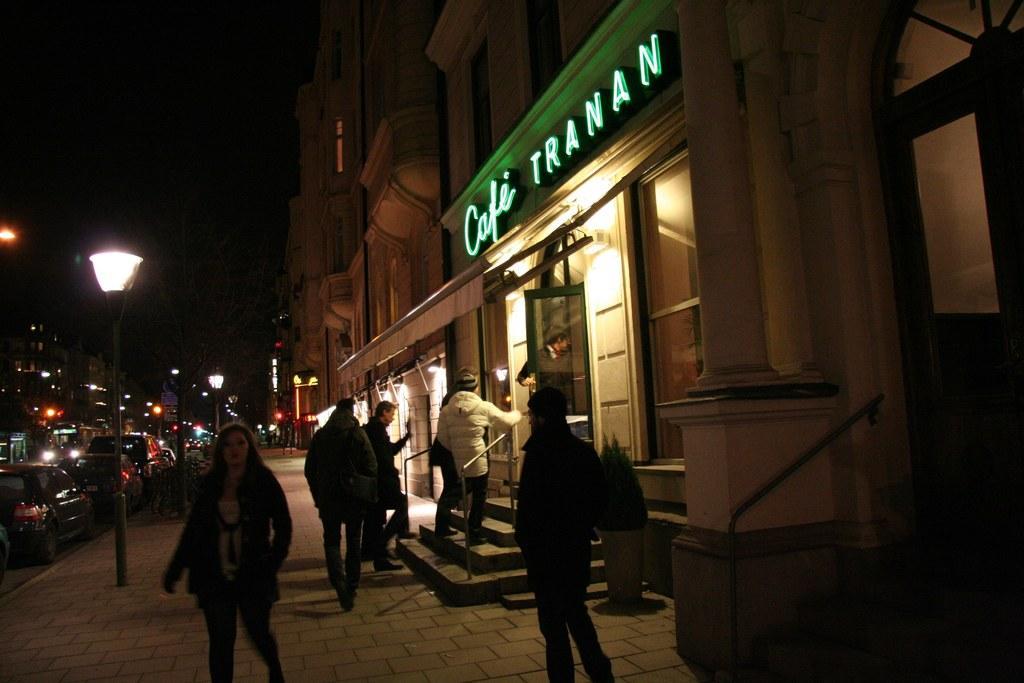In one or two sentences, can you explain what this image depicts? In this image we can see a few people walking on the pavement, there are a few cars on the road, there are street lights, a potted plant in front of the building, there is a building with text, stairs and door on the right side of the picture. 